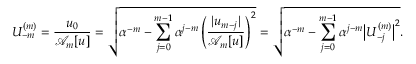Convert formula to latex. <formula><loc_0><loc_0><loc_500><loc_500>U _ { - m } ^ { ( m ) } = \frac { u _ { 0 } } { \mathcal { A } _ { m } [ u ] } = \sqrt { \alpha ^ { - m } - \sum _ { j = 0 } ^ { m - 1 } \alpha ^ { j - m } \left ( \frac { | u _ { m - j } | } { \mathcal { A } _ { m } [ u ] } \right ) ^ { 2 } } = \sqrt { \alpha ^ { - m } - \sum _ { j = 0 } ^ { m - 1 } \alpha ^ { j - m } \left | U _ { - j } ^ { ( m ) } \right | ^ { 2 } } .</formula> 